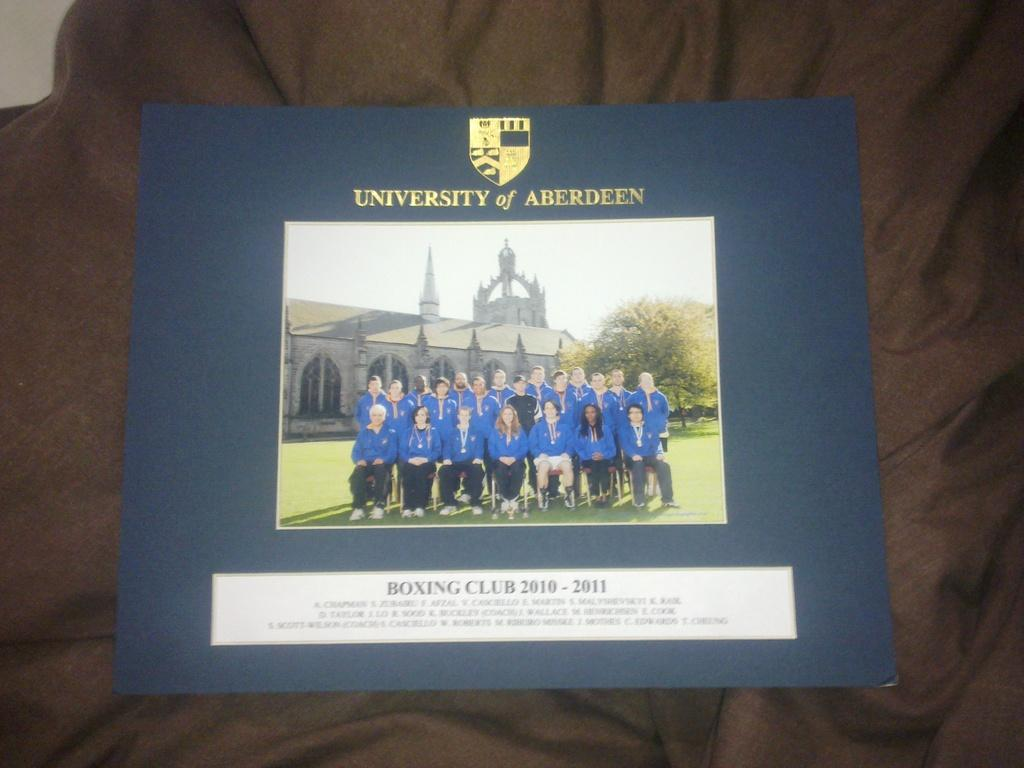<image>
Present a compact description of the photo's key features. The photo is of a group of medalists from the University of Aberdeen. 